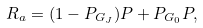<formula> <loc_0><loc_0><loc_500><loc_500>R _ { a } = ( 1 - P _ { G _ { J } } ) P + P _ { G _ { 0 } } P ,</formula> 